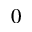<formula> <loc_0><loc_0><loc_500><loc_500>_ { 0 }</formula> 